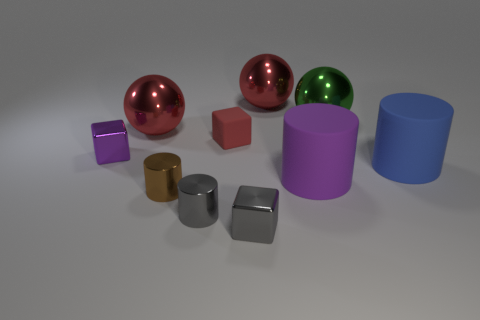What number of big objects are the same color as the matte cube?
Make the answer very short. 2. Are any purple blocks visible?
Offer a very short reply. Yes. What is the color of the small cylinder that is made of the same material as the small brown thing?
Provide a short and direct response. Gray. The metal block left of the red thing that is in front of the big ball to the left of the small red object is what color?
Your answer should be very brief. Purple. Do the brown object and the matte block behind the big blue cylinder have the same size?
Ensure brevity in your answer.  Yes. What number of objects are big shiny objects that are left of the small red matte object or rubber things to the left of the blue thing?
Ensure brevity in your answer.  3. There is a green thing that is the same size as the blue thing; what shape is it?
Your answer should be compact. Sphere. There is a small object behind the purple shiny cube that is on the left side of the cylinder right of the large purple rubber thing; what is its shape?
Your response must be concise. Cube. Is the number of big matte things that are to the right of the purple matte cylinder the same as the number of tiny red rubber blocks?
Your response must be concise. Yes. Does the purple shiny thing have the same size as the purple rubber cylinder?
Keep it short and to the point. No. 